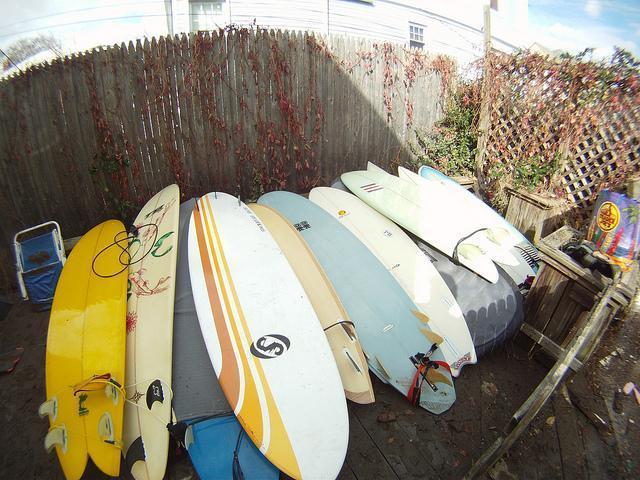How many surfboards are in the photo?
Give a very brief answer. 10. How many blue bottles are on the table?
Give a very brief answer. 0. 